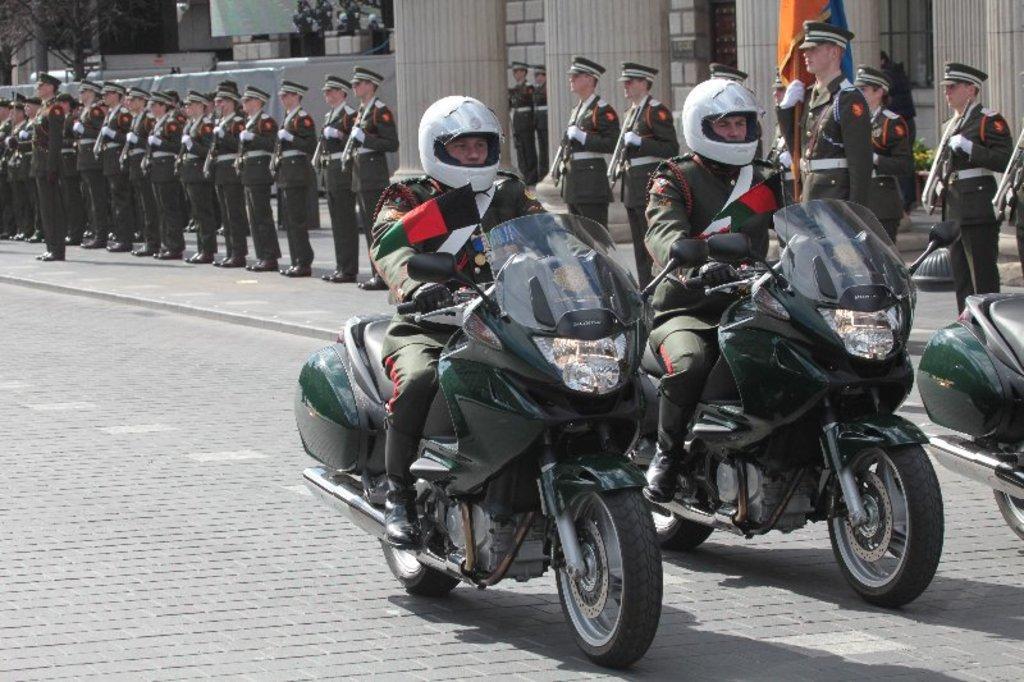Could you give a brief overview of what you see in this image? In this picture we can see two persons on the bike. They wear a helmet. This is the road and we can see some persons standing on the road. This is the pillar and these are the trees. 